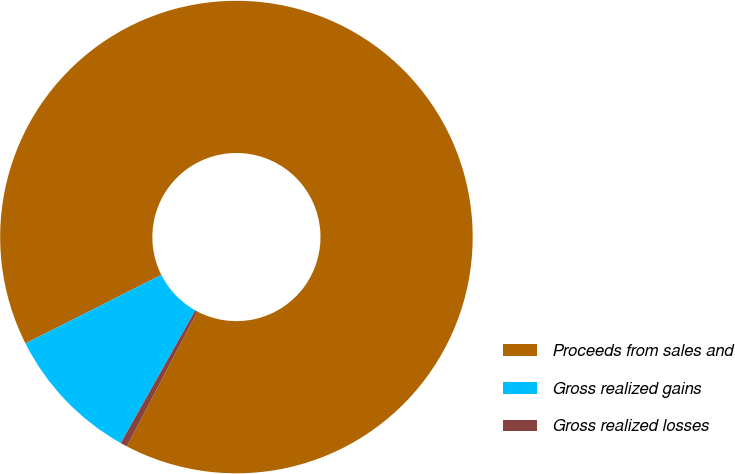Convert chart. <chart><loc_0><loc_0><loc_500><loc_500><pie_chart><fcel>Proceeds from sales and<fcel>Gross realized gains<fcel>Gross realized losses<nl><fcel>90.11%<fcel>9.43%<fcel>0.46%<nl></chart> 